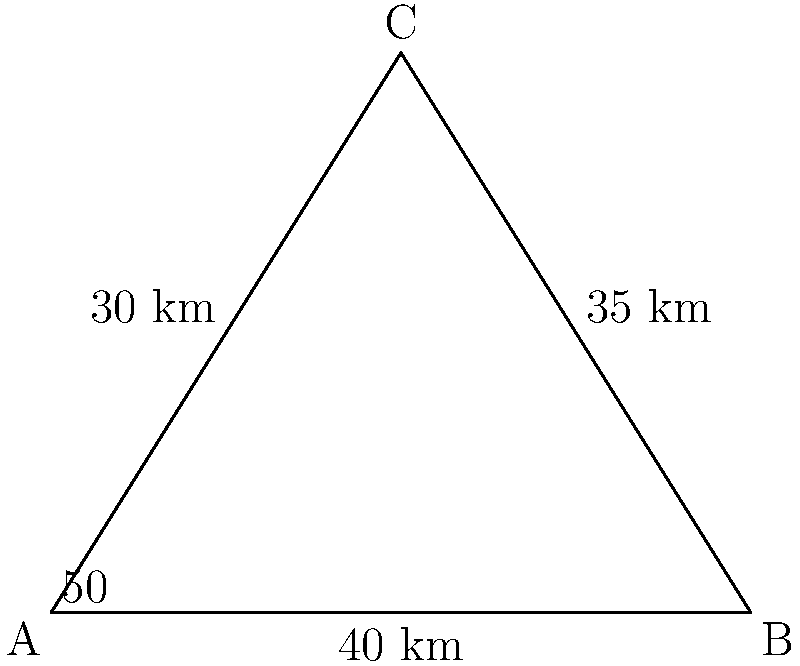Two campaign rally locations (A and B) are 40 km apart. A third location (C) is 30 km from A and 35 km from B. If the angle between the paths from A to B and A to C is 50°, what is the angle at location C? Round your answer to the nearest degree. To solve this problem, we'll use the law of cosines. Let's approach this step-by-step:

1) We're given:
   AB = 40 km
   AC = 30 km
   BC = 35 km
   Angle at A = 50°

2) We need to find the angle at C. Let's call this angle θ.

3) The law of cosines states:
   $a^2 = b^2 + c^2 - 2bc \cos(A)$

   Where a, b, and c are the lengths of the sides opposite to angles A, B, and C respectively.

4) Rearranging this to solve for cos(C):
   $\cos(C) = \frac{a^2 - b^2 - c^2}{-2bc}$

5) Substituting our known values:
   $\cos(θ) = \frac{40^2 - 30^2 - 35^2}{-2(30)(35)}$

6) Calculating:
   $\cos(θ) = \frac{1600 - 900 - 1225}{-2100} = \frac{-525}{-2100} = 0.25$

7) To find θ, we need to take the inverse cosine (arccos) of both sides:
   $θ = \arccos(0.25)$

8) Using a calculator and rounding to the nearest degree:
   $θ ≈ 76°$
Answer: 76° 